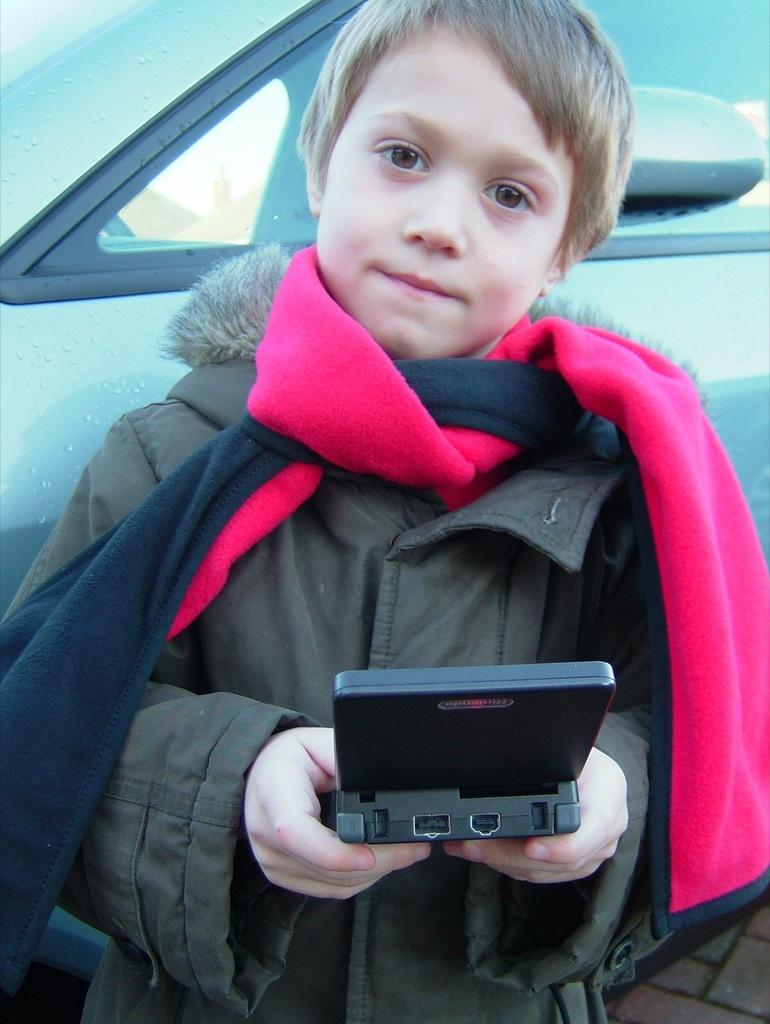What is the main subject of the picture? The main subject of the picture is a kid. What is the kid doing in the picture? The kid is standing in the picture. What is the kid wearing in the picture? The kid is wearing a jacket in the picture. What is the kid holding in the picture? The kid is holding an object in his hands in the picture. What can be seen behind the kid in the picture? There is a vehicle behind the kid in the picture. What type of arch can be seen in the picture? A: There is no arch present in the picture. What committee is responsible for the kid's attire in the picture? There is no committee involved in the kid's attire in the picture; it is simply the kid wearing a jacket. 